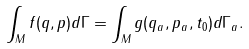<formula> <loc_0><loc_0><loc_500><loc_500>\int _ { M } f ( q , p ) d \Gamma = \int _ { M } g ( q _ { a } , p _ { a } , t _ { 0 } ) d \Gamma _ { a } .</formula> 